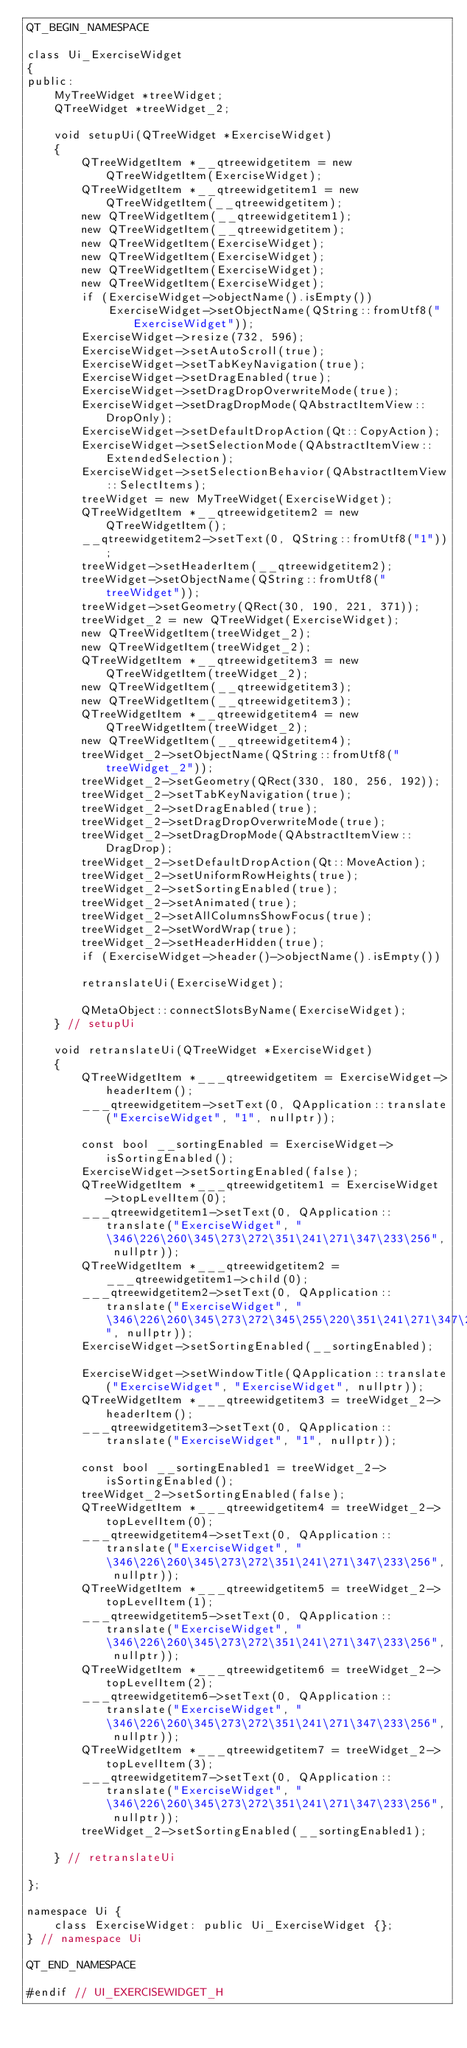<code> <loc_0><loc_0><loc_500><loc_500><_C_>QT_BEGIN_NAMESPACE

class Ui_ExerciseWidget
{
public:
    MyTreeWidget *treeWidget;
    QTreeWidget *treeWidget_2;

    void setupUi(QTreeWidget *ExerciseWidget)
    {
        QTreeWidgetItem *__qtreewidgetitem = new QTreeWidgetItem(ExerciseWidget);
        QTreeWidgetItem *__qtreewidgetitem1 = new QTreeWidgetItem(__qtreewidgetitem);
        new QTreeWidgetItem(__qtreewidgetitem1);
        new QTreeWidgetItem(__qtreewidgetitem);
        new QTreeWidgetItem(ExerciseWidget);
        new QTreeWidgetItem(ExerciseWidget);
        new QTreeWidgetItem(ExerciseWidget);
        new QTreeWidgetItem(ExerciseWidget);
        if (ExerciseWidget->objectName().isEmpty())
            ExerciseWidget->setObjectName(QString::fromUtf8("ExerciseWidget"));
        ExerciseWidget->resize(732, 596);
        ExerciseWidget->setAutoScroll(true);
        ExerciseWidget->setTabKeyNavigation(true);
        ExerciseWidget->setDragEnabled(true);
        ExerciseWidget->setDragDropOverwriteMode(true);
        ExerciseWidget->setDragDropMode(QAbstractItemView::DropOnly);
        ExerciseWidget->setDefaultDropAction(Qt::CopyAction);
        ExerciseWidget->setSelectionMode(QAbstractItemView::ExtendedSelection);
        ExerciseWidget->setSelectionBehavior(QAbstractItemView::SelectItems);
        treeWidget = new MyTreeWidget(ExerciseWidget);
        QTreeWidgetItem *__qtreewidgetitem2 = new QTreeWidgetItem();
        __qtreewidgetitem2->setText(0, QString::fromUtf8("1"));
        treeWidget->setHeaderItem(__qtreewidgetitem2);
        treeWidget->setObjectName(QString::fromUtf8("treeWidget"));
        treeWidget->setGeometry(QRect(30, 190, 221, 371));
        treeWidget_2 = new QTreeWidget(ExerciseWidget);
        new QTreeWidgetItem(treeWidget_2);
        new QTreeWidgetItem(treeWidget_2);
        QTreeWidgetItem *__qtreewidgetitem3 = new QTreeWidgetItem(treeWidget_2);
        new QTreeWidgetItem(__qtreewidgetitem3);
        new QTreeWidgetItem(__qtreewidgetitem3);
        QTreeWidgetItem *__qtreewidgetitem4 = new QTreeWidgetItem(treeWidget_2);
        new QTreeWidgetItem(__qtreewidgetitem4);
        treeWidget_2->setObjectName(QString::fromUtf8("treeWidget_2"));
        treeWidget_2->setGeometry(QRect(330, 180, 256, 192));
        treeWidget_2->setTabKeyNavigation(true);
        treeWidget_2->setDragEnabled(true);
        treeWidget_2->setDragDropOverwriteMode(true);
        treeWidget_2->setDragDropMode(QAbstractItemView::DragDrop);
        treeWidget_2->setDefaultDropAction(Qt::MoveAction);
        treeWidget_2->setUniformRowHeights(true);
        treeWidget_2->setSortingEnabled(true);
        treeWidget_2->setAnimated(true);
        treeWidget_2->setAllColumnsShowFocus(true);
        treeWidget_2->setWordWrap(true);
        treeWidget_2->setHeaderHidden(true);
        if (ExerciseWidget->header()->objectName().isEmpty())

        retranslateUi(ExerciseWidget);

        QMetaObject::connectSlotsByName(ExerciseWidget);
    } // setupUi

    void retranslateUi(QTreeWidget *ExerciseWidget)
    {
        QTreeWidgetItem *___qtreewidgetitem = ExerciseWidget->headerItem();
        ___qtreewidgetitem->setText(0, QApplication::translate("ExerciseWidget", "1", nullptr));

        const bool __sortingEnabled = ExerciseWidget->isSortingEnabled();
        ExerciseWidget->setSortingEnabled(false);
        QTreeWidgetItem *___qtreewidgetitem1 = ExerciseWidget->topLevelItem(0);
        ___qtreewidgetitem1->setText(0, QApplication::translate("ExerciseWidget", "\346\226\260\345\273\272\351\241\271\347\233\256", nullptr));
        QTreeWidgetItem *___qtreewidgetitem2 = ___qtreewidgetitem1->child(0);
        ___qtreewidgetitem2->setText(0, QApplication::translate("ExerciseWidget", "\346\226\260\345\273\272\345\255\220\351\241\271\347\233\256", nullptr));
        ExerciseWidget->setSortingEnabled(__sortingEnabled);

        ExerciseWidget->setWindowTitle(QApplication::translate("ExerciseWidget", "ExerciseWidget", nullptr));
        QTreeWidgetItem *___qtreewidgetitem3 = treeWidget_2->headerItem();
        ___qtreewidgetitem3->setText(0, QApplication::translate("ExerciseWidget", "1", nullptr));

        const bool __sortingEnabled1 = treeWidget_2->isSortingEnabled();
        treeWidget_2->setSortingEnabled(false);
        QTreeWidgetItem *___qtreewidgetitem4 = treeWidget_2->topLevelItem(0);
        ___qtreewidgetitem4->setText(0, QApplication::translate("ExerciseWidget", "\346\226\260\345\273\272\351\241\271\347\233\256", nullptr));
        QTreeWidgetItem *___qtreewidgetitem5 = treeWidget_2->topLevelItem(1);
        ___qtreewidgetitem5->setText(0, QApplication::translate("ExerciseWidget", "\346\226\260\345\273\272\351\241\271\347\233\256", nullptr));
        QTreeWidgetItem *___qtreewidgetitem6 = treeWidget_2->topLevelItem(2);
        ___qtreewidgetitem6->setText(0, QApplication::translate("ExerciseWidget", "\346\226\260\345\273\272\351\241\271\347\233\256", nullptr));
        QTreeWidgetItem *___qtreewidgetitem7 = treeWidget_2->topLevelItem(3);
        ___qtreewidgetitem7->setText(0, QApplication::translate("ExerciseWidget", "\346\226\260\345\273\272\351\241\271\347\233\256", nullptr));
        treeWidget_2->setSortingEnabled(__sortingEnabled1);

    } // retranslateUi

};

namespace Ui {
    class ExerciseWidget: public Ui_ExerciseWidget {};
} // namespace Ui

QT_END_NAMESPACE

#endif // UI_EXERCISEWIDGET_H
</code> 